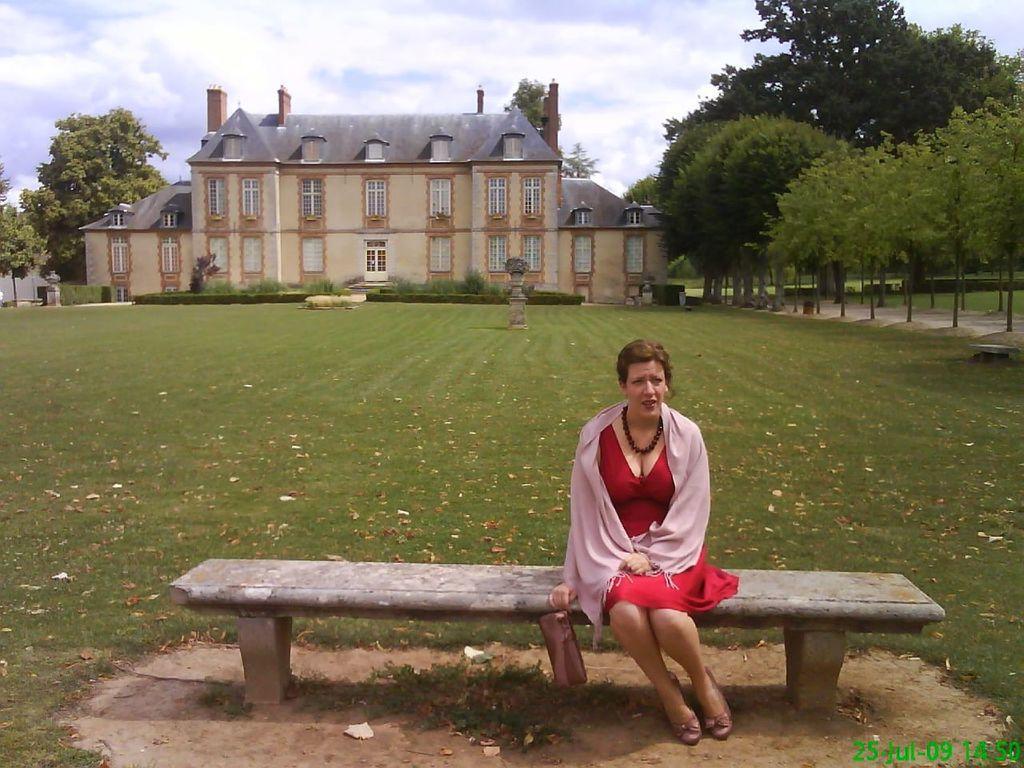Can you describe this image briefly? In this image I can see a woman sitting on bench in the foreground, in the background there are some trees, building, the sky visible. 